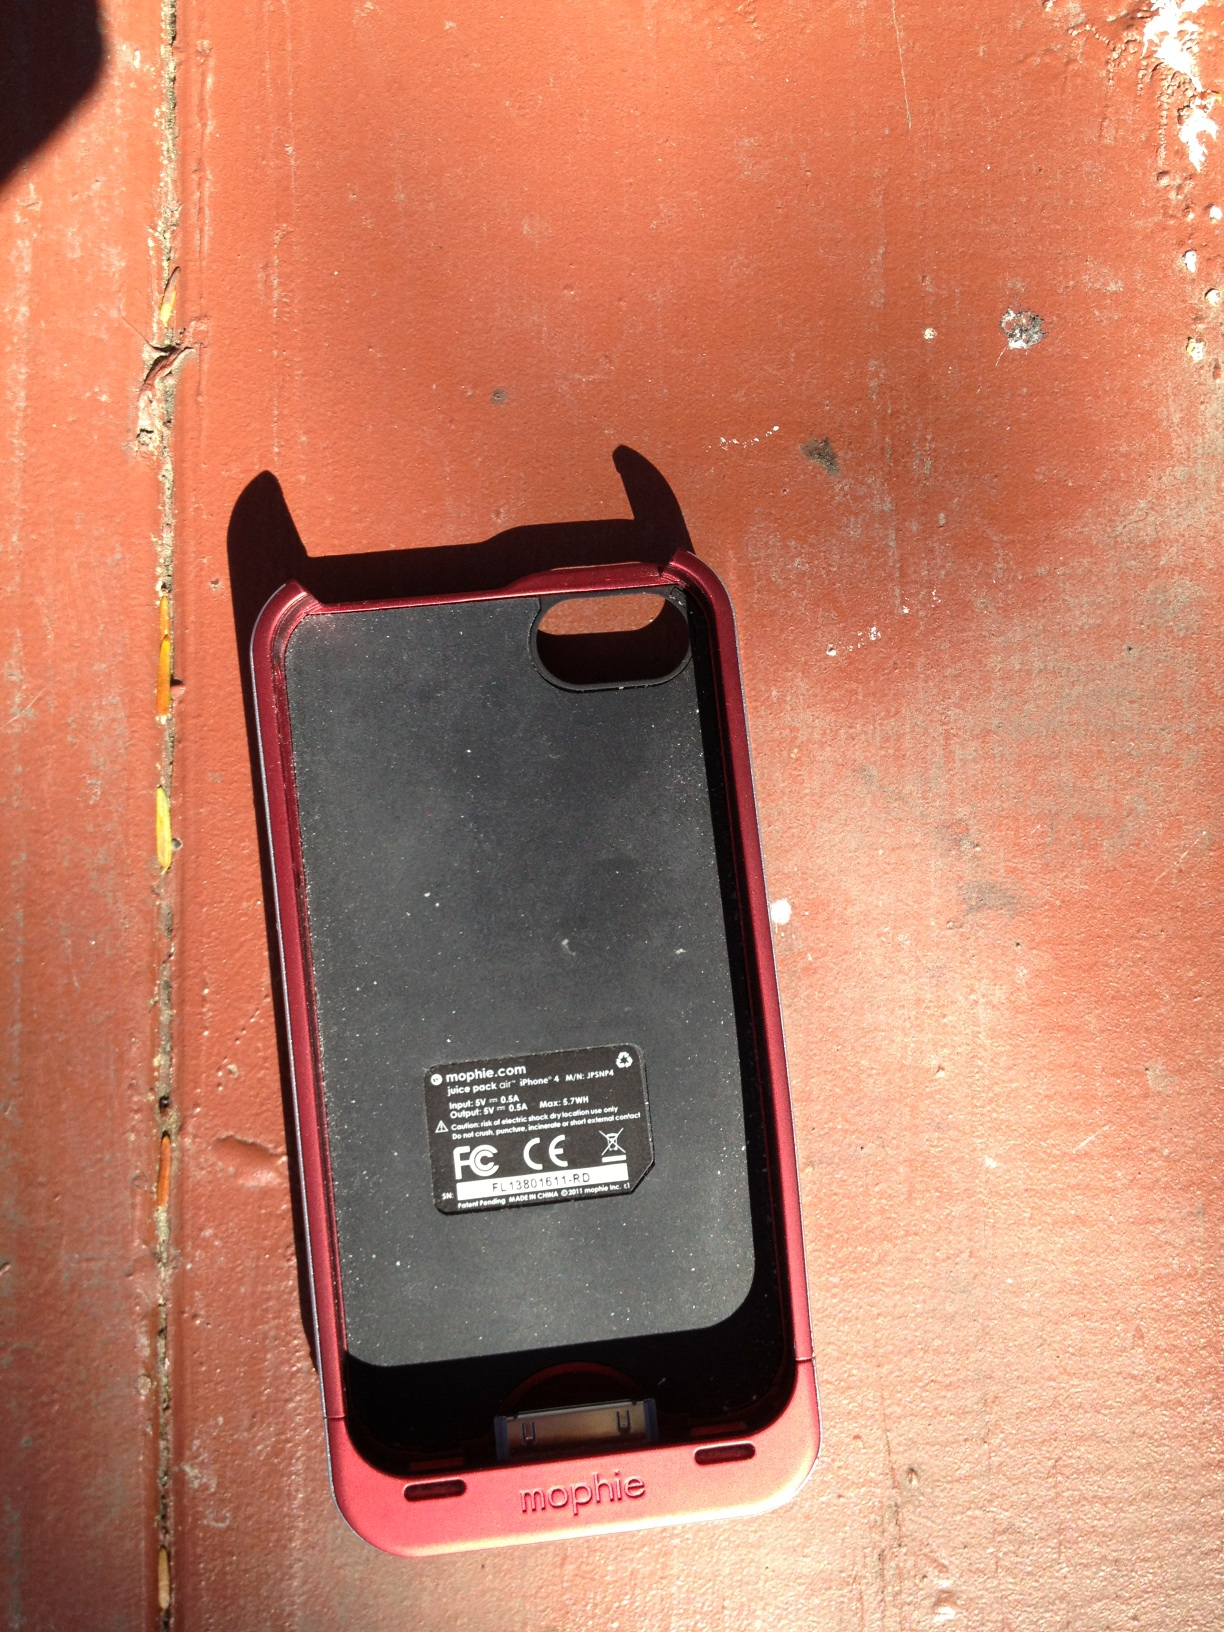Can you explain the purpose of the markings and text on the back of this phone case? The markings and text on the back of the phone case provide information about the manufacturer (Mophie), regulatory compliance (FCC statement), and the model details. These are essential for ensuring product safety and authenticity. 